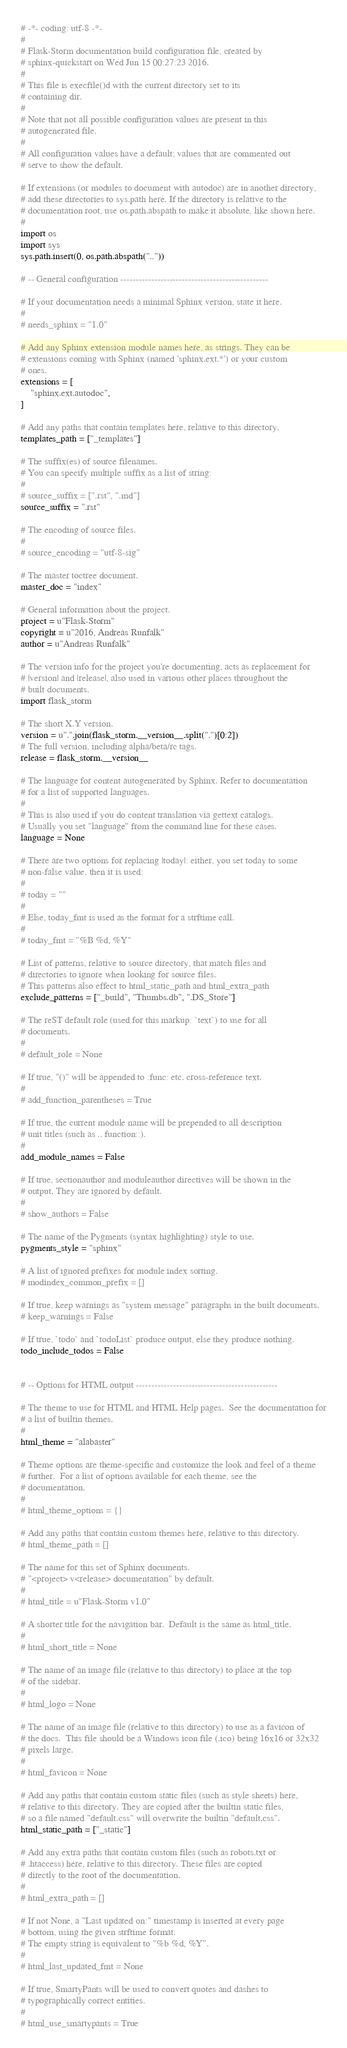<code> <loc_0><loc_0><loc_500><loc_500><_Python_># -*- coding: utf-8 -*-
#
# Flask-Storm documentation build configuration file, created by
# sphinx-quickstart on Wed Jun 15 00:27:23 2016.
#
# This file is execfile()d with the current directory set to its
# containing dir.
#
# Note that not all possible configuration values are present in this
# autogenerated file.
#
# All configuration values have a default; values that are commented out
# serve to show the default.

# If extensions (or modules to document with autodoc) are in another directory,
# add these directories to sys.path here. If the directory is relative to the
# documentation root, use os.path.abspath to make it absolute, like shown here.
#
import os
import sys
sys.path.insert(0, os.path.abspath(".."))

# -- General configuration ------------------------------------------------

# If your documentation needs a minimal Sphinx version, state it here.
#
# needs_sphinx = "1.0"

# Add any Sphinx extension module names here, as strings. They can be
# extensions coming with Sphinx (named 'sphinx.ext.*') or your custom
# ones.
extensions = [
    "sphinx.ext.autodoc",
]

# Add any paths that contain templates here, relative to this directory.
templates_path = ["_templates"]

# The suffix(es) of source filenames.
# You can specify multiple suffix as a list of string:
#
# source_suffix = [".rst", ".md"]
source_suffix = ".rst"

# The encoding of source files.
#
# source_encoding = "utf-8-sig"

# The master toctree document.
master_doc = "index"

# General information about the project.
project = u"Flask-Storm"
copyright = u"2016, Andreas Runfalk"
author = u"Andreas Runfalk"

# The version info for the project you're documenting, acts as replacement for
# |version| and |release|, also used in various other places throughout the
# built documents.
import flask_storm

# The short X.Y version.
version = u".".join(flask_storm.__version__.split(".")[0:2])
# The full version, including alpha/beta/rc tags.
release = flask_storm.__version__

# The language for content autogenerated by Sphinx. Refer to documentation
# for a list of supported languages.
#
# This is also used if you do content translation via gettext catalogs.
# Usually you set "language" from the command line for these cases.
language = None

# There are two options for replacing |today|: either, you set today to some
# non-false value, then it is used:
#
# today = ""
#
# Else, today_fmt is used as the format for a strftime call.
#
# today_fmt = "%B %d, %Y"

# List of patterns, relative to source directory, that match files and
# directories to ignore when looking for source files.
# This patterns also effect to html_static_path and html_extra_path
exclude_patterns = ["_build", "Thumbs.db", ".DS_Store"]

# The reST default role (used for this markup: `text`) to use for all
# documents.
#
# default_role = None

# If true, "()" will be appended to :func: etc. cross-reference text.
#
# add_function_parentheses = True

# If true, the current module name will be prepended to all description
# unit titles (such as .. function::).
#
add_module_names = False

# If true, sectionauthor and moduleauthor directives will be shown in the
# output. They are ignored by default.
#
# show_authors = False

# The name of the Pygments (syntax highlighting) style to use.
pygments_style = "sphinx"

# A list of ignored prefixes for module index sorting.
# modindex_common_prefix = []

# If true, keep warnings as "system message" paragraphs in the built documents.
# keep_warnings = False

# If true, `todo` and `todoList` produce output, else they produce nothing.
todo_include_todos = False


# -- Options for HTML output ----------------------------------------------

# The theme to use for HTML and HTML Help pages.  See the documentation for
# a list of builtin themes.
#
html_theme = "alabaster"

# Theme options are theme-specific and customize the look and feel of a theme
# further.  For a list of options available for each theme, see the
# documentation.
#
# html_theme_options = {}

# Add any paths that contain custom themes here, relative to this directory.
# html_theme_path = []

# The name for this set of Sphinx documents.
# "<project> v<release> documentation" by default.
#
# html_title = u"Flask-Storm v1.0"

# A shorter title for the navigation bar.  Default is the same as html_title.
#
# html_short_title = None

# The name of an image file (relative to this directory) to place at the top
# of the sidebar.
#
# html_logo = None

# The name of an image file (relative to this directory) to use as a favicon of
# the docs.  This file should be a Windows icon file (.ico) being 16x16 or 32x32
# pixels large.
#
# html_favicon = None

# Add any paths that contain custom static files (such as style sheets) here,
# relative to this directory. They are copied after the builtin static files,
# so a file named "default.css" will overwrite the builtin "default.css".
html_static_path = ["_static"]

# Add any extra paths that contain custom files (such as robots.txt or
# .htaccess) here, relative to this directory. These files are copied
# directly to the root of the documentation.
#
# html_extra_path = []

# If not None, a "Last updated on:" timestamp is inserted at every page
# bottom, using the given strftime format.
# The empty string is equivalent to "%b %d, %Y".
#
# html_last_updated_fmt = None

# If true, SmartyPants will be used to convert quotes and dashes to
# typographically correct entities.
#
# html_use_smartypants = True
</code> 